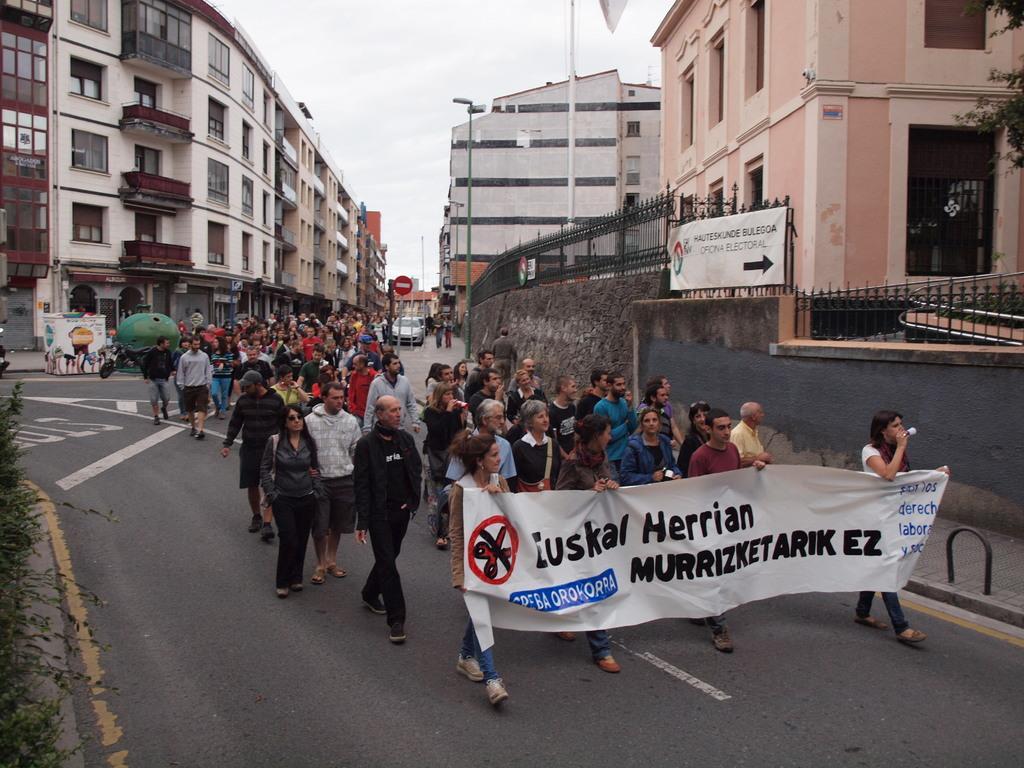Could you give a brief overview of what you see in this image? In the image there are many people walking on the roads, they are protesting against something, they are holding a banner in the foreground and around them there are many buildings. 